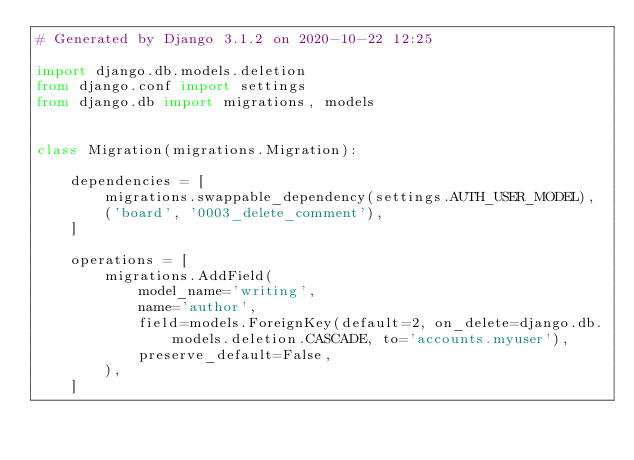<code> <loc_0><loc_0><loc_500><loc_500><_Python_># Generated by Django 3.1.2 on 2020-10-22 12:25

import django.db.models.deletion
from django.conf import settings
from django.db import migrations, models


class Migration(migrations.Migration):

    dependencies = [
        migrations.swappable_dependency(settings.AUTH_USER_MODEL),
        ('board', '0003_delete_comment'),
    ]

    operations = [
        migrations.AddField(
            model_name='writing',
            name='author',
            field=models.ForeignKey(default=2, on_delete=django.db.models.deletion.CASCADE, to='accounts.myuser'),
            preserve_default=False,
        ),
    ]
</code> 